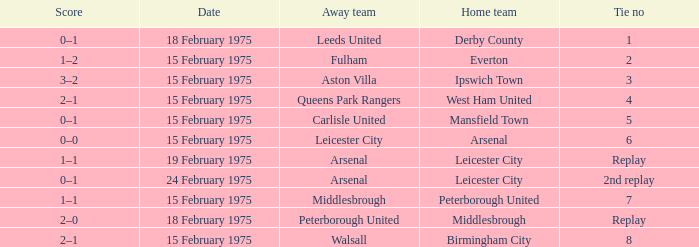What was the tie number when peterborough united was the away team? Replay. 